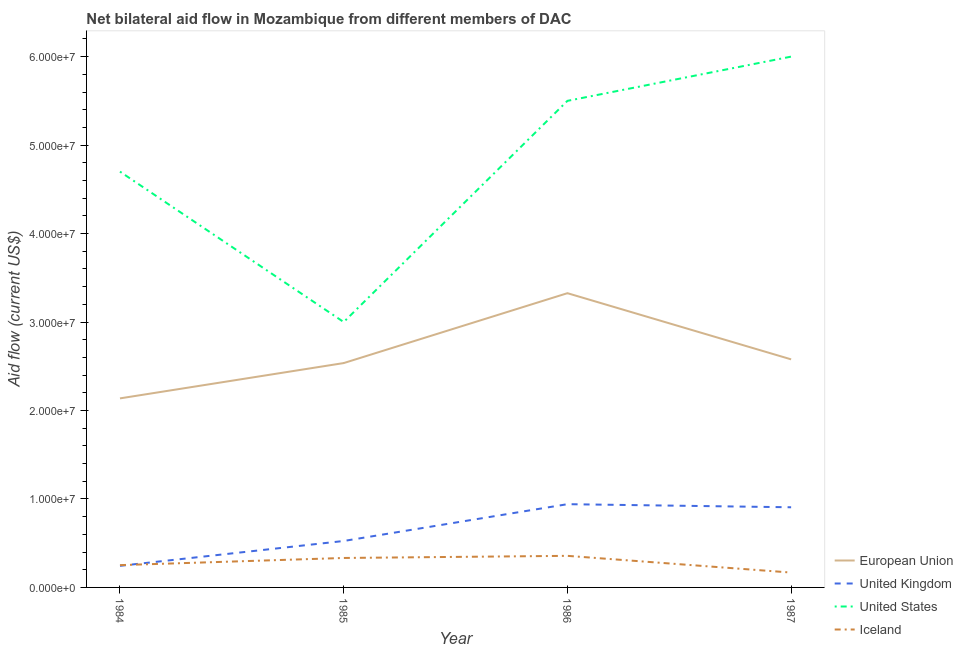How many different coloured lines are there?
Offer a terse response. 4. What is the amount of aid given by uk in 1986?
Ensure brevity in your answer.  9.41e+06. Across all years, what is the maximum amount of aid given by iceland?
Your response must be concise. 3.57e+06. Across all years, what is the minimum amount of aid given by eu?
Your answer should be very brief. 2.14e+07. In which year was the amount of aid given by us maximum?
Provide a succinct answer. 1987. What is the total amount of aid given by eu in the graph?
Your response must be concise. 1.06e+08. What is the difference between the amount of aid given by iceland in 1984 and that in 1985?
Keep it short and to the point. -8.10e+05. What is the difference between the amount of aid given by us in 1984 and the amount of aid given by uk in 1987?
Your answer should be compact. 3.79e+07. What is the average amount of aid given by iceland per year?
Ensure brevity in your answer.  2.78e+06. In the year 1986, what is the difference between the amount of aid given by iceland and amount of aid given by uk?
Keep it short and to the point. -5.84e+06. What is the ratio of the amount of aid given by uk in 1984 to that in 1987?
Your response must be concise. 0.27. Is the amount of aid given by iceland in 1984 less than that in 1986?
Offer a terse response. Yes. What is the difference between the highest and the lowest amount of aid given by us?
Make the answer very short. 3.00e+07. Is it the case that in every year, the sum of the amount of aid given by iceland and amount of aid given by us is greater than the sum of amount of aid given by eu and amount of aid given by uk?
Your answer should be very brief. No. Is it the case that in every year, the sum of the amount of aid given by eu and amount of aid given by uk is greater than the amount of aid given by us?
Provide a short and direct response. No. How many years are there in the graph?
Offer a very short reply. 4. Does the graph contain any zero values?
Give a very brief answer. No. Does the graph contain grids?
Offer a very short reply. No. What is the title of the graph?
Provide a succinct answer. Net bilateral aid flow in Mozambique from different members of DAC. What is the Aid flow (current US$) of European Union in 1984?
Provide a succinct answer. 2.14e+07. What is the Aid flow (current US$) in United Kingdom in 1984?
Keep it short and to the point. 2.44e+06. What is the Aid flow (current US$) of United States in 1984?
Give a very brief answer. 4.70e+07. What is the Aid flow (current US$) of Iceland in 1984?
Your response must be concise. 2.52e+06. What is the Aid flow (current US$) in European Union in 1985?
Provide a short and direct response. 2.54e+07. What is the Aid flow (current US$) of United Kingdom in 1985?
Offer a terse response. 5.25e+06. What is the Aid flow (current US$) in United States in 1985?
Give a very brief answer. 3.00e+07. What is the Aid flow (current US$) in Iceland in 1985?
Make the answer very short. 3.33e+06. What is the Aid flow (current US$) of European Union in 1986?
Provide a short and direct response. 3.33e+07. What is the Aid flow (current US$) of United Kingdom in 1986?
Give a very brief answer. 9.41e+06. What is the Aid flow (current US$) of United States in 1986?
Your answer should be compact. 5.50e+07. What is the Aid flow (current US$) in Iceland in 1986?
Give a very brief answer. 3.57e+06. What is the Aid flow (current US$) in European Union in 1987?
Your answer should be very brief. 2.58e+07. What is the Aid flow (current US$) in United Kingdom in 1987?
Provide a short and direct response. 9.06e+06. What is the Aid flow (current US$) in United States in 1987?
Ensure brevity in your answer.  6.00e+07. What is the Aid flow (current US$) of Iceland in 1987?
Give a very brief answer. 1.68e+06. Across all years, what is the maximum Aid flow (current US$) in European Union?
Provide a succinct answer. 3.33e+07. Across all years, what is the maximum Aid flow (current US$) of United Kingdom?
Offer a terse response. 9.41e+06. Across all years, what is the maximum Aid flow (current US$) of United States?
Your answer should be very brief. 6.00e+07. Across all years, what is the maximum Aid flow (current US$) in Iceland?
Ensure brevity in your answer.  3.57e+06. Across all years, what is the minimum Aid flow (current US$) of European Union?
Offer a terse response. 2.14e+07. Across all years, what is the minimum Aid flow (current US$) in United Kingdom?
Provide a short and direct response. 2.44e+06. Across all years, what is the minimum Aid flow (current US$) of United States?
Ensure brevity in your answer.  3.00e+07. Across all years, what is the minimum Aid flow (current US$) of Iceland?
Keep it short and to the point. 1.68e+06. What is the total Aid flow (current US$) in European Union in the graph?
Offer a terse response. 1.06e+08. What is the total Aid flow (current US$) in United Kingdom in the graph?
Give a very brief answer. 2.62e+07. What is the total Aid flow (current US$) of United States in the graph?
Your answer should be very brief. 1.92e+08. What is the total Aid flow (current US$) of Iceland in the graph?
Offer a very short reply. 1.11e+07. What is the difference between the Aid flow (current US$) in European Union in 1984 and that in 1985?
Your response must be concise. -3.99e+06. What is the difference between the Aid flow (current US$) of United Kingdom in 1984 and that in 1985?
Offer a very short reply. -2.81e+06. What is the difference between the Aid flow (current US$) in United States in 1984 and that in 1985?
Your answer should be very brief. 1.70e+07. What is the difference between the Aid flow (current US$) in Iceland in 1984 and that in 1985?
Your response must be concise. -8.10e+05. What is the difference between the Aid flow (current US$) of European Union in 1984 and that in 1986?
Your answer should be very brief. -1.19e+07. What is the difference between the Aid flow (current US$) of United Kingdom in 1984 and that in 1986?
Offer a very short reply. -6.97e+06. What is the difference between the Aid flow (current US$) in United States in 1984 and that in 1986?
Your answer should be compact. -8.00e+06. What is the difference between the Aid flow (current US$) of Iceland in 1984 and that in 1986?
Ensure brevity in your answer.  -1.05e+06. What is the difference between the Aid flow (current US$) in European Union in 1984 and that in 1987?
Make the answer very short. -4.41e+06. What is the difference between the Aid flow (current US$) in United Kingdom in 1984 and that in 1987?
Your answer should be compact. -6.62e+06. What is the difference between the Aid flow (current US$) in United States in 1984 and that in 1987?
Offer a very short reply. -1.30e+07. What is the difference between the Aid flow (current US$) in Iceland in 1984 and that in 1987?
Your answer should be compact. 8.40e+05. What is the difference between the Aid flow (current US$) of European Union in 1985 and that in 1986?
Your answer should be very brief. -7.90e+06. What is the difference between the Aid flow (current US$) in United Kingdom in 1985 and that in 1986?
Provide a short and direct response. -4.16e+06. What is the difference between the Aid flow (current US$) in United States in 1985 and that in 1986?
Keep it short and to the point. -2.50e+07. What is the difference between the Aid flow (current US$) in Iceland in 1985 and that in 1986?
Your answer should be compact. -2.40e+05. What is the difference between the Aid flow (current US$) in European Union in 1985 and that in 1987?
Your response must be concise. -4.20e+05. What is the difference between the Aid flow (current US$) of United Kingdom in 1985 and that in 1987?
Ensure brevity in your answer.  -3.81e+06. What is the difference between the Aid flow (current US$) of United States in 1985 and that in 1987?
Offer a terse response. -3.00e+07. What is the difference between the Aid flow (current US$) in Iceland in 1985 and that in 1987?
Offer a very short reply. 1.65e+06. What is the difference between the Aid flow (current US$) in European Union in 1986 and that in 1987?
Your response must be concise. 7.48e+06. What is the difference between the Aid flow (current US$) of United Kingdom in 1986 and that in 1987?
Make the answer very short. 3.50e+05. What is the difference between the Aid flow (current US$) in United States in 1986 and that in 1987?
Give a very brief answer. -5.00e+06. What is the difference between the Aid flow (current US$) of Iceland in 1986 and that in 1987?
Your answer should be compact. 1.89e+06. What is the difference between the Aid flow (current US$) in European Union in 1984 and the Aid flow (current US$) in United Kingdom in 1985?
Provide a succinct answer. 1.61e+07. What is the difference between the Aid flow (current US$) of European Union in 1984 and the Aid flow (current US$) of United States in 1985?
Provide a succinct answer. -8.63e+06. What is the difference between the Aid flow (current US$) of European Union in 1984 and the Aid flow (current US$) of Iceland in 1985?
Your answer should be compact. 1.80e+07. What is the difference between the Aid flow (current US$) of United Kingdom in 1984 and the Aid flow (current US$) of United States in 1985?
Your answer should be compact. -2.76e+07. What is the difference between the Aid flow (current US$) of United Kingdom in 1984 and the Aid flow (current US$) of Iceland in 1985?
Ensure brevity in your answer.  -8.90e+05. What is the difference between the Aid flow (current US$) in United States in 1984 and the Aid flow (current US$) in Iceland in 1985?
Make the answer very short. 4.37e+07. What is the difference between the Aid flow (current US$) in European Union in 1984 and the Aid flow (current US$) in United Kingdom in 1986?
Offer a very short reply. 1.20e+07. What is the difference between the Aid flow (current US$) in European Union in 1984 and the Aid flow (current US$) in United States in 1986?
Make the answer very short. -3.36e+07. What is the difference between the Aid flow (current US$) in European Union in 1984 and the Aid flow (current US$) in Iceland in 1986?
Provide a succinct answer. 1.78e+07. What is the difference between the Aid flow (current US$) in United Kingdom in 1984 and the Aid flow (current US$) in United States in 1986?
Your answer should be compact. -5.26e+07. What is the difference between the Aid flow (current US$) in United Kingdom in 1984 and the Aid flow (current US$) in Iceland in 1986?
Give a very brief answer. -1.13e+06. What is the difference between the Aid flow (current US$) of United States in 1984 and the Aid flow (current US$) of Iceland in 1986?
Give a very brief answer. 4.34e+07. What is the difference between the Aid flow (current US$) of European Union in 1984 and the Aid flow (current US$) of United Kingdom in 1987?
Keep it short and to the point. 1.23e+07. What is the difference between the Aid flow (current US$) of European Union in 1984 and the Aid flow (current US$) of United States in 1987?
Offer a terse response. -3.86e+07. What is the difference between the Aid flow (current US$) in European Union in 1984 and the Aid flow (current US$) in Iceland in 1987?
Keep it short and to the point. 1.97e+07. What is the difference between the Aid flow (current US$) of United Kingdom in 1984 and the Aid flow (current US$) of United States in 1987?
Offer a very short reply. -5.76e+07. What is the difference between the Aid flow (current US$) in United Kingdom in 1984 and the Aid flow (current US$) in Iceland in 1987?
Provide a short and direct response. 7.60e+05. What is the difference between the Aid flow (current US$) in United States in 1984 and the Aid flow (current US$) in Iceland in 1987?
Give a very brief answer. 4.53e+07. What is the difference between the Aid flow (current US$) of European Union in 1985 and the Aid flow (current US$) of United Kingdom in 1986?
Provide a succinct answer. 1.60e+07. What is the difference between the Aid flow (current US$) of European Union in 1985 and the Aid flow (current US$) of United States in 1986?
Provide a short and direct response. -2.96e+07. What is the difference between the Aid flow (current US$) in European Union in 1985 and the Aid flow (current US$) in Iceland in 1986?
Your answer should be very brief. 2.18e+07. What is the difference between the Aid flow (current US$) of United Kingdom in 1985 and the Aid flow (current US$) of United States in 1986?
Provide a short and direct response. -4.98e+07. What is the difference between the Aid flow (current US$) in United Kingdom in 1985 and the Aid flow (current US$) in Iceland in 1986?
Keep it short and to the point. 1.68e+06. What is the difference between the Aid flow (current US$) of United States in 1985 and the Aid flow (current US$) of Iceland in 1986?
Make the answer very short. 2.64e+07. What is the difference between the Aid flow (current US$) in European Union in 1985 and the Aid flow (current US$) in United Kingdom in 1987?
Your response must be concise. 1.63e+07. What is the difference between the Aid flow (current US$) in European Union in 1985 and the Aid flow (current US$) in United States in 1987?
Your response must be concise. -3.46e+07. What is the difference between the Aid flow (current US$) of European Union in 1985 and the Aid flow (current US$) of Iceland in 1987?
Offer a very short reply. 2.37e+07. What is the difference between the Aid flow (current US$) in United Kingdom in 1985 and the Aid flow (current US$) in United States in 1987?
Your answer should be very brief. -5.48e+07. What is the difference between the Aid flow (current US$) of United Kingdom in 1985 and the Aid flow (current US$) of Iceland in 1987?
Give a very brief answer. 3.57e+06. What is the difference between the Aid flow (current US$) in United States in 1985 and the Aid flow (current US$) in Iceland in 1987?
Your answer should be very brief. 2.83e+07. What is the difference between the Aid flow (current US$) in European Union in 1986 and the Aid flow (current US$) in United Kingdom in 1987?
Give a very brief answer. 2.42e+07. What is the difference between the Aid flow (current US$) of European Union in 1986 and the Aid flow (current US$) of United States in 1987?
Your answer should be very brief. -2.67e+07. What is the difference between the Aid flow (current US$) of European Union in 1986 and the Aid flow (current US$) of Iceland in 1987?
Ensure brevity in your answer.  3.16e+07. What is the difference between the Aid flow (current US$) in United Kingdom in 1986 and the Aid flow (current US$) in United States in 1987?
Your answer should be very brief. -5.06e+07. What is the difference between the Aid flow (current US$) of United Kingdom in 1986 and the Aid flow (current US$) of Iceland in 1987?
Ensure brevity in your answer.  7.73e+06. What is the difference between the Aid flow (current US$) in United States in 1986 and the Aid flow (current US$) in Iceland in 1987?
Your answer should be very brief. 5.33e+07. What is the average Aid flow (current US$) in European Union per year?
Give a very brief answer. 2.64e+07. What is the average Aid flow (current US$) in United Kingdom per year?
Offer a terse response. 6.54e+06. What is the average Aid flow (current US$) in United States per year?
Ensure brevity in your answer.  4.80e+07. What is the average Aid flow (current US$) of Iceland per year?
Ensure brevity in your answer.  2.78e+06. In the year 1984, what is the difference between the Aid flow (current US$) of European Union and Aid flow (current US$) of United Kingdom?
Your response must be concise. 1.89e+07. In the year 1984, what is the difference between the Aid flow (current US$) in European Union and Aid flow (current US$) in United States?
Offer a terse response. -2.56e+07. In the year 1984, what is the difference between the Aid flow (current US$) of European Union and Aid flow (current US$) of Iceland?
Your answer should be compact. 1.88e+07. In the year 1984, what is the difference between the Aid flow (current US$) in United Kingdom and Aid flow (current US$) in United States?
Ensure brevity in your answer.  -4.46e+07. In the year 1984, what is the difference between the Aid flow (current US$) of United States and Aid flow (current US$) of Iceland?
Offer a terse response. 4.45e+07. In the year 1985, what is the difference between the Aid flow (current US$) of European Union and Aid flow (current US$) of United Kingdom?
Your response must be concise. 2.01e+07. In the year 1985, what is the difference between the Aid flow (current US$) in European Union and Aid flow (current US$) in United States?
Your answer should be very brief. -4.64e+06. In the year 1985, what is the difference between the Aid flow (current US$) of European Union and Aid flow (current US$) of Iceland?
Your answer should be very brief. 2.20e+07. In the year 1985, what is the difference between the Aid flow (current US$) in United Kingdom and Aid flow (current US$) in United States?
Provide a succinct answer. -2.48e+07. In the year 1985, what is the difference between the Aid flow (current US$) of United Kingdom and Aid flow (current US$) of Iceland?
Offer a terse response. 1.92e+06. In the year 1985, what is the difference between the Aid flow (current US$) of United States and Aid flow (current US$) of Iceland?
Ensure brevity in your answer.  2.67e+07. In the year 1986, what is the difference between the Aid flow (current US$) of European Union and Aid flow (current US$) of United Kingdom?
Make the answer very short. 2.38e+07. In the year 1986, what is the difference between the Aid flow (current US$) of European Union and Aid flow (current US$) of United States?
Your answer should be compact. -2.17e+07. In the year 1986, what is the difference between the Aid flow (current US$) in European Union and Aid flow (current US$) in Iceland?
Give a very brief answer. 2.97e+07. In the year 1986, what is the difference between the Aid flow (current US$) of United Kingdom and Aid flow (current US$) of United States?
Offer a very short reply. -4.56e+07. In the year 1986, what is the difference between the Aid flow (current US$) in United Kingdom and Aid flow (current US$) in Iceland?
Your response must be concise. 5.84e+06. In the year 1986, what is the difference between the Aid flow (current US$) in United States and Aid flow (current US$) in Iceland?
Your response must be concise. 5.14e+07. In the year 1987, what is the difference between the Aid flow (current US$) of European Union and Aid flow (current US$) of United Kingdom?
Provide a succinct answer. 1.67e+07. In the year 1987, what is the difference between the Aid flow (current US$) in European Union and Aid flow (current US$) in United States?
Your answer should be compact. -3.42e+07. In the year 1987, what is the difference between the Aid flow (current US$) of European Union and Aid flow (current US$) of Iceland?
Provide a succinct answer. 2.41e+07. In the year 1987, what is the difference between the Aid flow (current US$) in United Kingdom and Aid flow (current US$) in United States?
Provide a succinct answer. -5.09e+07. In the year 1987, what is the difference between the Aid flow (current US$) in United Kingdom and Aid flow (current US$) in Iceland?
Offer a very short reply. 7.38e+06. In the year 1987, what is the difference between the Aid flow (current US$) of United States and Aid flow (current US$) of Iceland?
Provide a succinct answer. 5.83e+07. What is the ratio of the Aid flow (current US$) in European Union in 1984 to that in 1985?
Give a very brief answer. 0.84. What is the ratio of the Aid flow (current US$) of United Kingdom in 1984 to that in 1985?
Your answer should be very brief. 0.46. What is the ratio of the Aid flow (current US$) in United States in 1984 to that in 1985?
Provide a succinct answer. 1.57. What is the ratio of the Aid flow (current US$) of Iceland in 1984 to that in 1985?
Make the answer very short. 0.76. What is the ratio of the Aid flow (current US$) in European Union in 1984 to that in 1986?
Offer a very short reply. 0.64. What is the ratio of the Aid flow (current US$) of United Kingdom in 1984 to that in 1986?
Keep it short and to the point. 0.26. What is the ratio of the Aid flow (current US$) of United States in 1984 to that in 1986?
Your response must be concise. 0.85. What is the ratio of the Aid flow (current US$) in Iceland in 1984 to that in 1986?
Give a very brief answer. 0.71. What is the ratio of the Aid flow (current US$) in European Union in 1984 to that in 1987?
Your response must be concise. 0.83. What is the ratio of the Aid flow (current US$) in United Kingdom in 1984 to that in 1987?
Your response must be concise. 0.27. What is the ratio of the Aid flow (current US$) of United States in 1984 to that in 1987?
Provide a succinct answer. 0.78. What is the ratio of the Aid flow (current US$) of European Union in 1985 to that in 1986?
Your answer should be very brief. 0.76. What is the ratio of the Aid flow (current US$) in United Kingdom in 1985 to that in 1986?
Your response must be concise. 0.56. What is the ratio of the Aid flow (current US$) in United States in 1985 to that in 1986?
Make the answer very short. 0.55. What is the ratio of the Aid flow (current US$) of Iceland in 1985 to that in 1986?
Give a very brief answer. 0.93. What is the ratio of the Aid flow (current US$) in European Union in 1985 to that in 1987?
Your answer should be compact. 0.98. What is the ratio of the Aid flow (current US$) in United Kingdom in 1985 to that in 1987?
Offer a terse response. 0.58. What is the ratio of the Aid flow (current US$) in United States in 1985 to that in 1987?
Offer a very short reply. 0.5. What is the ratio of the Aid flow (current US$) of Iceland in 1985 to that in 1987?
Keep it short and to the point. 1.98. What is the ratio of the Aid flow (current US$) in European Union in 1986 to that in 1987?
Your response must be concise. 1.29. What is the ratio of the Aid flow (current US$) of United Kingdom in 1986 to that in 1987?
Your answer should be very brief. 1.04. What is the ratio of the Aid flow (current US$) in Iceland in 1986 to that in 1987?
Your answer should be very brief. 2.12. What is the difference between the highest and the second highest Aid flow (current US$) of European Union?
Offer a terse response. 7.48e+06. What is the difference between the highest and the second highest Aid flow (current US$) in United States?
Your answer should be very brief. 5.00e+06. What is the difference between the highest and the second highest Aid flow (current US$) of Iceland?
Make the answer very short. 2.40e+05. What is the difference between the highest and the lowest Aid flow (current US$) of European Union?
Keep it short and to the point. 1.19e+07. What is the difference between the highest and the lowest Aid flow (current US$) in United Kingdom?
Provide a short and direct response. 6.97e+06. What is the difference between the highest and the lowest Aid flow (current US$) of United States?
Give a very brief answer. 3.00e+07. What is the difference between the highest and the lowest Aid flow (current US$) of Iceland?
Offer a very short reply. 1.89e+06. 